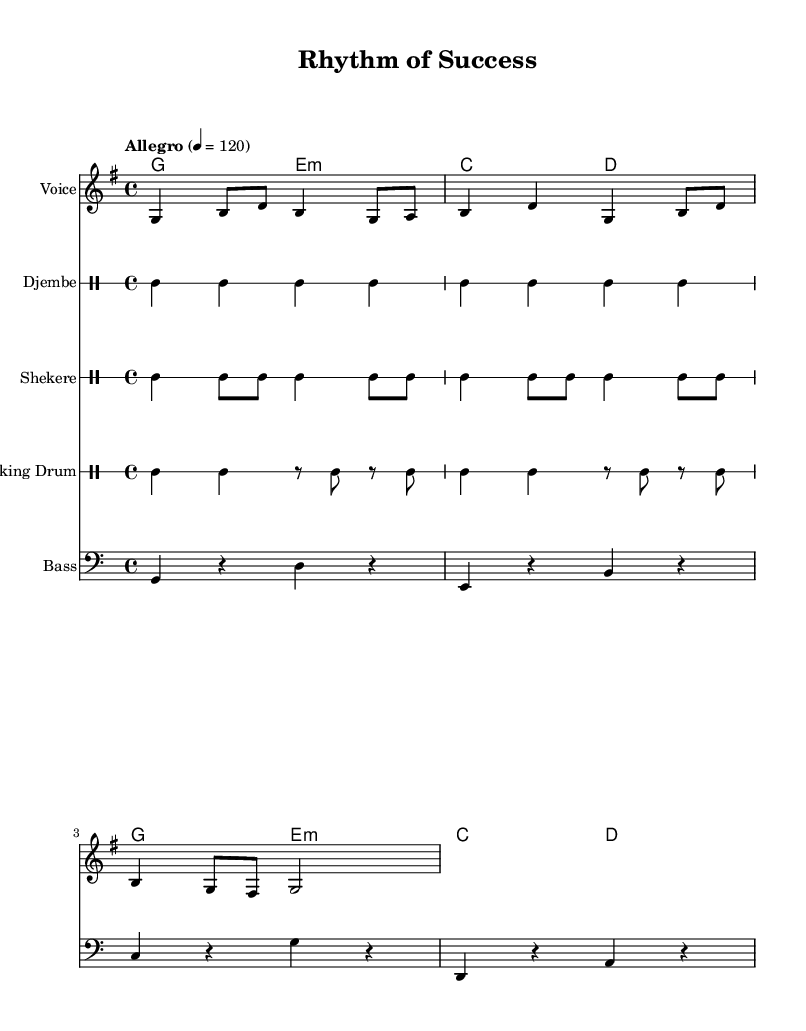What is the key signature of this music? The key signature has one sharp, which indicates it is in G major.
Answer: G major What is the time signature of this music? The time signature is represented in the notation at the beginning of the score, which shows four beats in each measure.
Answer: 4/4 What is the tempo marking given in the music? The tempo is indicated at the beginning of the piece as "Allegro" which typically means fast and lively, with a specific metronome marking of 120 beats per minute.
Answer: 120 What types of drums are used in this piece? The music score includes three types of drums: djembe, shekere, and talking drum, each represented on separate drum staffs.
Answer: Djembe, shekere, talking drum How many measures are in the melody section? Counting the measures in the melody part, there are a total of 6 measures displayed in the score.
Answer: 6 measures What kind of harmony is being used? The harmony consists of major and minor chords, specifically G major, E minor, C major, and D major, which accompany the melody.
Answer: Major and minor chords What is the lyrical theme of the lyrics provided? The lyrics convey themes of teamwork and vision, focusing on unity and a bright future, which aligns with the business theme of the piece.
Answer: Teamwork, vision 